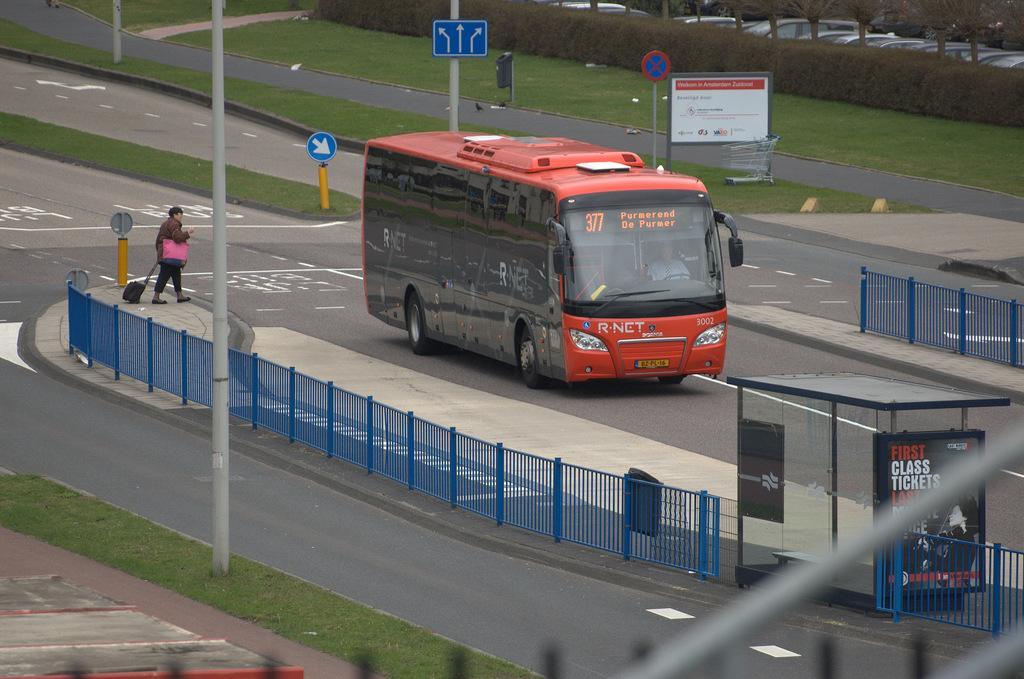How would you summarize this image in a sentence or two? There is a bus on the road. Here we can see fence, boards, poles, grass, and plants. There is a person on the platform. In the background we can see vehicles and trees. 